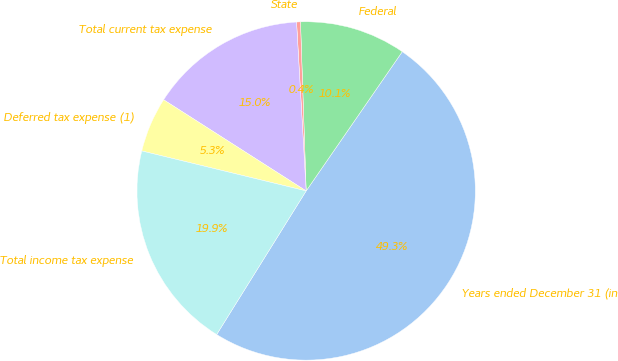Convert chart. <chart><loc_0><loc_0><loc_500><loc_500><pie_chart><fcel>Years ended December 31 (in<fcel>Federal<fcel>State<fcel>Total current tax expense<fcel>Deferred tax expense (1)<fcel>Total income tax expense<nl><fcel>49.26%<fcel>10.15%<fcel>0.37%<fcel>15.04%<fcel>5.26%<fcel>19.93%<nl></chart> 